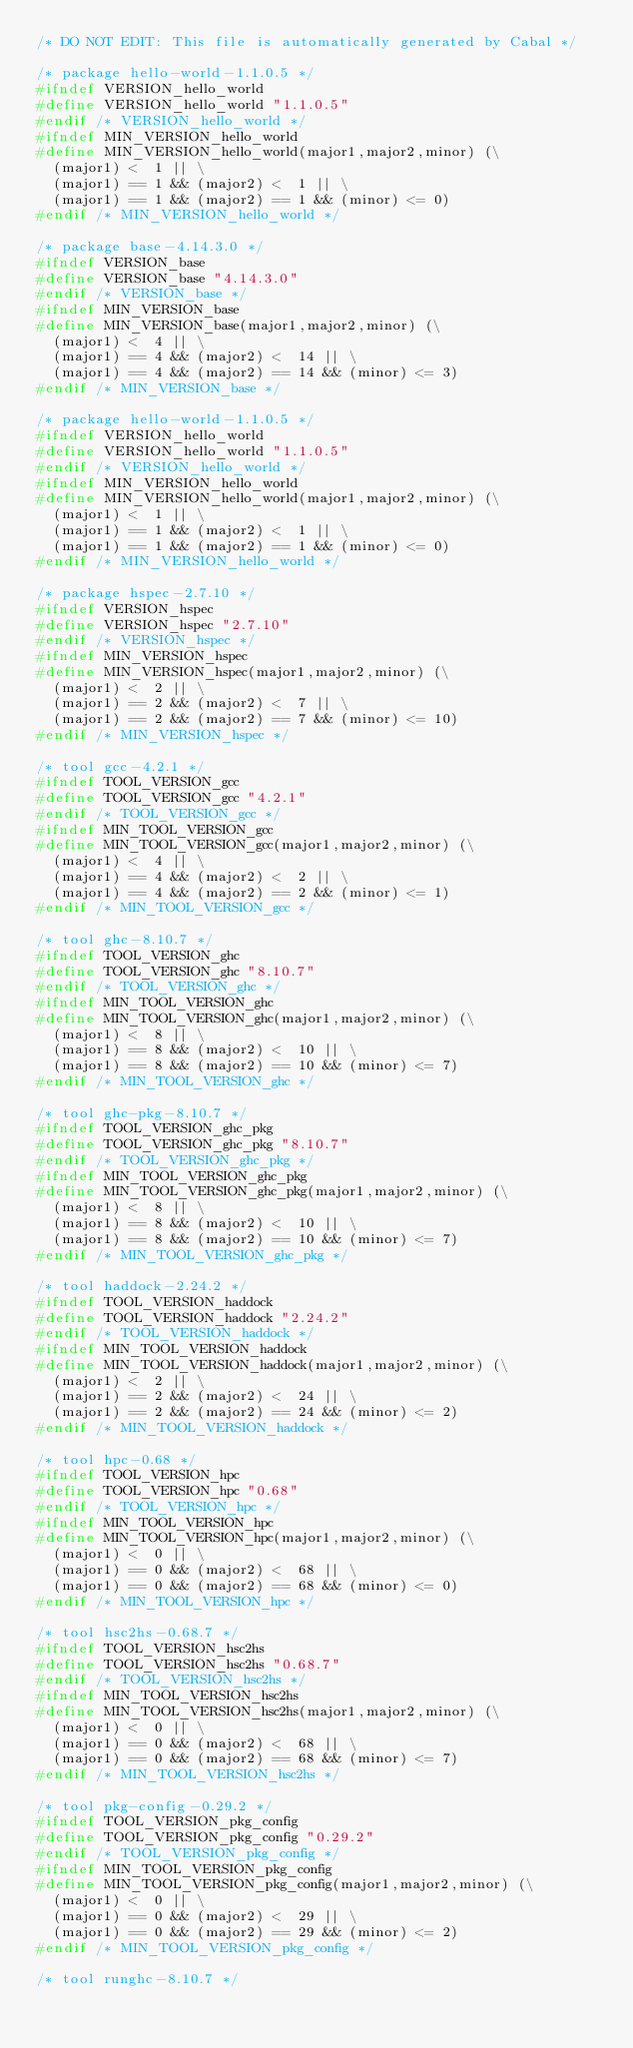<code> <loc_0><loc_0><loc_500><loc_500><_C_>/* DO NOT EDIT: This file is automatically generated by Cabal */

/* package hello-world-1.1.0.5 */
#ifndef VERSION_hello_world
#define VERSION_hello_world "1.1.0.5"
#endif /* VERSION_hello_world */
#ifndef MIN_VERSION_hello_world
#define MIN_VERSION_hello_world(major1,major2,minor) (\
  (major1) <  1 || \
  (major1) == 1 && (major2) <  1 || \
  (major1) == 1 && (major2) == 1 && (minor) <= 0)
#endif /* MIN_VERSION_hello_world */

/* package base-4.14.3.0 */
#ifndef VERSION_base
#define VERSION_base "4.14.3.0"
#endif /* VERSION_base */
#ifndef MIN_VERSION_base
#define MIN_VERSION_base(major1,major2,minor) (\
  (major1) <  4 || \
  (major1) == 4 && (major2) <  14 || \
  (major1) == 4 && (major2) == 14 && (minor) <= 3)
#endif /* MIN_VERSION_base */

/* package hello-world-1.1.0.5 */
#ifndef VERSION_hello_world
#define VERSION_hello_world "1.1.0.5"
#endif /* VERSION_hello_world */
#ifndef MIN_VERSION_hello_world
#define MIN_VERSION_hello_world(major1,major2,minor) (\
  (major1) <  1 || \
  (major1) == 1 && (major2) <  1 || \
  (major1) == 1 && (major2) == 1 && (minor) <= 0)
#endif /* MIN_VERSION_hello_world */

/* package hspec-2.7.10 */
#ifndef VERSION_hspec
#define VERSION_hspec "2.7.10"
#endif /* VERSION_hspec */
#ifndef MIN_VERSION_hspec
#define MIN_VERSION_hspec(major1,major2,minor) (\
  (major1) <  2 || \
  (major1) == 2 && (major2) <  7 || \
  (major1) == 2 && (major2) == 7 && (minor) <= 10)
#endif /* MIN_VERSION_hspec */

/* tool gcc-4.2.1 */
#ifndef TOOL_VERSION_gcc
#define TOOL_VERSION_gcc "4.2.1"
#endif /* TOOL_VERSION_gcc */
#ifndef MIN_TOOL_VERSION_gcc
#define MIN_TOOL_VERSION_gcc(major1,major2,minor) (\
  (major1) <  4 || \
  (major1) == 4 && (major2) <  2 || \
  (major1) == 4 && (major2) == 2 && (minor) <= 1)
#endif /* MIN_TOOL_VERSION_gcc */

/* tool ghc-8.10.7 */
#ifndef TOOL_VERSION_ghc
#define TOOL_VERSION_ghc "8.10.7"
#endif /* TOOL_VERSION_ghc */
#ifndef MIN_TOOL_VERSION_ghc
#define MIN_TOOL_VERSION_ghc(major1,major2,minor) (\
  (major1) <  8 || \
  (major1) == 8 && (major2) <  10 || \
  (major1) == 8 && (major2) == 10 && (minor) <= 7)
#endif /* MIN_TOOL_VERSION_ghc */

/* tool ghc-pkg-8.10.7 */
#ifndef TOOL_VERSION_ghc_pkg
#define TOOL_VERSION_ghc_pkg "8.10.7"
#endif /* TOOL_VERSION_ghc_pkg */
#ifndef MIN_TOOL_VERSION_ghc_pkg
#define MIN_TOOL_VERSION_ghc_pkg(major1,major2,minor) (\
  (major1) <  8 || \
  (major1) == 8 && (major2) <  10 || \
  (major1) == 8 && (major2) == 10 && (minor) <= 7)
#endif /* MIN_TOOL_VERSION_ghc_pkg */

/* tool haddock-2.24.2 */
#ifndef TOOL_VERSION_haddock
#define TOOL_VERSION_haddock "2.24.2"
#endif /* TOOL_VERSION_haddock */
#ifndef MIN_TOOL_VERSION_haddock
#define MIN_TOOL_VERSION_haddock(major1,major2,minor) (\
  (major1) <  2 || \
  (major1) == 2 && (major2) <  24 || \
  (major1) == 2 && (major2) == 24 && (minor) <= 2)
#endif /* MIN_TOOL_VERSION_haddock */

/* tool hpc-0.68 */
#ifndef TOOL_VERSION_hpc
#define TOOL_VERSION_hpc "0.68"
#endif /* TOOL_VERSION_hpc */
#ifndef MIN_TOOL_VERSION_hpc
#define MIN_TOOL_VERSION_hpc(major1,major2,minor) (\
  (major1) <  0 || \
  (major1) == 0 && (major2) <  68 || \
  (major1) == 0 && (major2) == 68 && (minor) <= 0)
#endif /* MIN_TOOL_VERSION_hpc */

/* tool hsc2hs-0.68.7 */
#ifndef TOOL_VERSION_hsc2hs
#define TOOL_VERSION_hsc2hs "0.68.7"
#endif /* TOOL_VERSION_hsc2hs */
#ifndef MIN_TOOL_VERSION_hsc2hs
#define MIN_TOOL_VERSION_hsc2hs(major1,major2,minor) (\
  (major1) <  0 || \
  (major1) == 0 && (major2) <  68 || \
  (major1) == 0 && (major2) == 68 && (minor) <= 7)
#endif /* MIN_TOOL_VERSION_hsc2hs */

/* tool pkg-config-0.29.2 */
#ifndef TOOL_VERSION_pkg_config
#define TOOL_VERSION_pkg_config "0.29.2"
#endif /* TOOL_VERSION_pkg_config */
#ifndef MIN_TOOL_VERSION_pkg_config
#define MIN_TOOL_VERSION_pkg_config(major1,major2,minor) (\
  (major1) <  0 || \
  (major1) == 0 && (major2) <  29 || \
  (major1) == 0 && (major2) == 29 && (minor) <= 2)
#endif /* MIN_TOOL_VERSION_pkg_config */

/* tool runghc-8.10.7 */</code> 